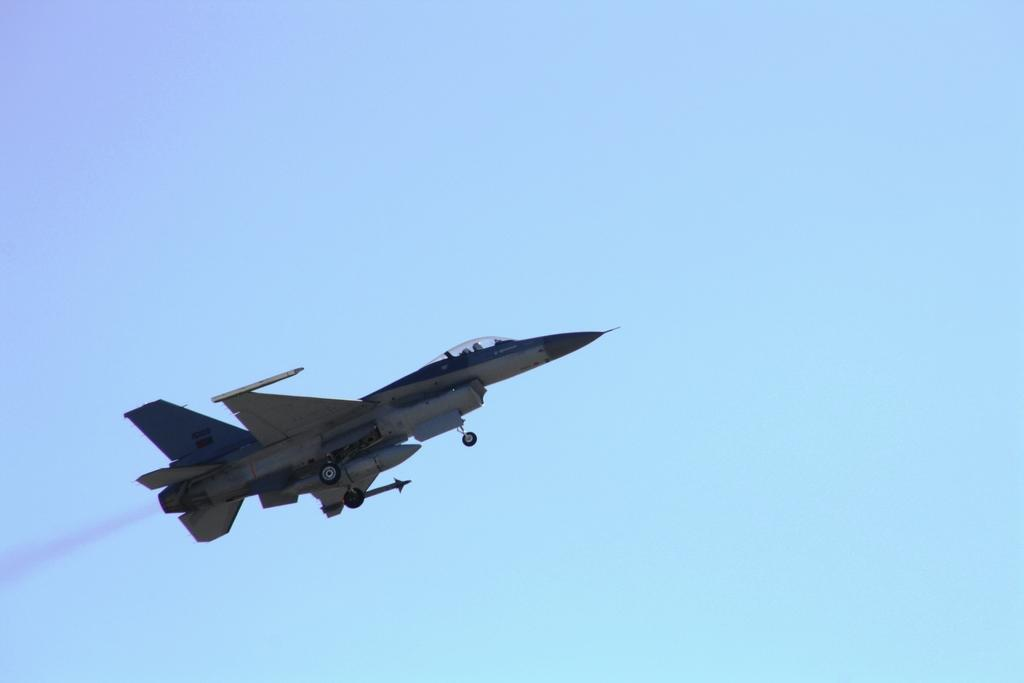What is the main subject of the image? The main subject of the image is an aircraft. Where is the aircraft located in the image? The aircraft is in the air in the image. What can be seen coming from the aircraft? There is smoke visible in the image. What is the color of the background in the image? The background of the image is blue. Can you see any kittens protesting at the harbor in the image? There are no kittens, protest, or harbor present in the image. 